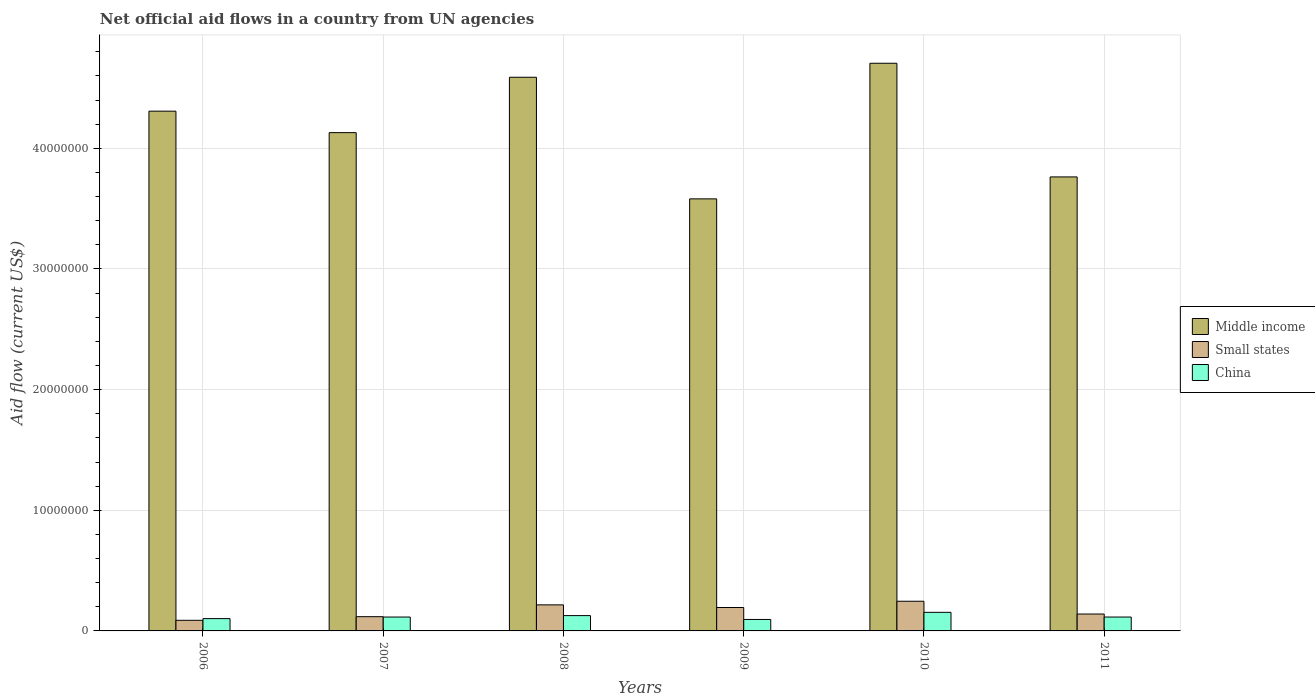How many different coloured bars are there?
Give a very brief answer. 3. How many groups of bars are there?
Your response must be concise. 6. Are the number of bars per tick equal to the number of legend labels?
Make the answer very short. Yes. Are the number of bars on each tick of the X-axis equal?
Keep it short and to the point. Yes. In how many cases, is the number of bars for a given year not equal to the number of legend labels?
Your response must be concise. 0. What is the net official aid flow in Small states in 2006?
Provide a short and direct response. 8.80e+05. Across all years, what is the maximum net official aid flow in China?
Make the answer very short. 1.54e+06. Across all years, what is the minimum net official aid flow in Middle income?
Offer a terse response. 3.58e+07. In which year was the net official aid flow in Middle income maximum?
Give a very brief answer. 2010. What is the total net official aid flow in Small states in the graph?
Provide a succinct answer. 1.00e+07. What is the difference between the net official aid flow in China in 2008 and that in 2011?
Give a very brief answer. 1.20e+05. What is the difference between the net official aid flow in Small states in 2010 and the net official aid flow in Middle income in 2009?
Make the answer very short. -3.34e+07. What is the average net official aid flow in Middle income per year?
Your answer should be very brief. 4.18e+07. In the year 2010, what is the difference between the net official aid flow in Small states and net official aid flow in China?
Your answer should be compact. 9.20e+05. What is the ratio of the net official aid flow in Small states in 2009 to that in 2011?
Provide a succinct answer. 1.39. Is the net official aid flow in Small states in 2006 less than that in 2007?
Ensure brevity in your answer.  Yes. What is the difference between the highest and the second highest net official aid flow in China?
Make the answer very short. 2.70e+05. What is the difference between the highest and the lowest net official aid flow in Middle income?
Offer a terse response. 1.12e+07. Is the sum of the net official aid flow in Small states in 2008 and 2011 greater than the maximum net official aid flow in China across all years?
Make the answer very short. Yes. What does the 1st bar from the left in 2010 represents?
Provide a succinct answer. Middle income. What does the 2nd bar from the right in 2010 represents?
Give a very brief answer. Small states. Is it the case that in every year, the sum of the net official aid flow in Middle income and net official aid flow in Small states is greater than the net official aid flow in China?
Keep it short and to the point. Yes. What is the difference between two consecutive major ticks on the Y-axis?
Your answer should be very brief. 1.00e+07. Are the values on the major ticks of Y-axis written in scientific E-notation?
Your answer should be compact. No. Does the graph contain any zero values?
Keep it short and to the point. No. Does the graph contain grids?
Offer a terse response. Yes. How many legend labels are there?
Your response must be concise. 3. What is the title of the graph?
Offer a terse response. Net official aid flows in a country from UN agencies. Does "Panama" appear as one of the legend labels in the graph?
Give a very brief answer. No. What is the label or title of the Y-axis?
Your answer should be compact. Aid flow (current US$). What is the Aid flow (current US$) in Middle income in 2006?
Offer a very short reply. 4.31e+07. What is the Aid flow (current US$) in Small states in 2006?
Make the answer very short. 8.80e+05. What is the Aid flow (current US$) of China in 2006?
Offer a very short reply. 1.02e+06. What is the Aid flow (current US$) of Middle income in 2007?
Provide a succinct answer. 4.13e+07. What is the Aid flow (current US$) in Small states in 2007?
Your answer should be very brief. 1.18e+06. What is the Aid flow (current US$) of China in 2007?
Your response must be concise. 1.15e+06. What is the Aid flow (current US$) of Middle income in 2008?
Your answer should be compact. 4.59e+07. What is the Aid flow (current US$) of Small states in 2008?
Offer a very short reply. 2.16e+06. What is the Aid flow (current US$) in China in 2008?
Your response must be concise. 1.27e+06. What is the Aid flow (current US$) in Middle income in 2009?
Provide a short and direct response. 3.58e+07. What is the Aid flow (current US$) of Small states in 2009?
Keep it short and to the point. 1.94e+06. What is the Aid flow (current US$) of China in 2009?
Your answer should be compact. 9.50e+05. What is the Aid flow (current US$) in Middle income in 2010?
Provide a short and direct response. 4.70e+07. What is the Aid flow (current US$) in Small states in 2010?
Provide a succinct answer. 2.46e+06. What is the Aid flow (current US$) of China in 2010?
Offer a very short reply. 1.54e+06. What is the Aid flow (current US$) in Middle income in 2011?
Ensure brevity in your answer.  3.76e+07. What is the Aid flow (current US$) of Small states in 2011?
Provide a succinct answer. 1.40e+06. What is the Aid flow (current US$) in China in 2011?
Give a very brief answer. 1.15e+06. Across all years, what is the maximum Aid flow (current US$) in Middle income?
Ensure brevity in your answer.  4.70e+07. Across all years, what is the maximum Aid flow (current US$) in Small states?
Provide a succinct answer. 2.46e+06. Across all years, what is the maximum Aid flow (current US$) in China?
Your answer should be very brief. 1.54e+06. Across all years, what is the minimum Aid flow (current US$) of Middle income?
Make the answer very short. 3.58e+07. Across all years, what is the minimum Aid flow (current US$) in Small states?
Provide a short and direct response. 8.80e+05. Across all years, what is the minimum Aid flow (current US$) in China?
Give a very brief answer. 9.50e+05. What is the total Aid flow (current US$) in Middle income in the graph?
Keep it short and to the point. 2.51e+08. What is the total Aid flow (current US$) in Small states in the graph?
Provide a succinct answer. 1.00e+07. What is the total Aid flow (current US$) of China in the graph?
Give a very brief answer. 7.08e+06. What is the difference between the Aid flow (current US$) in Middle income in 2006 and that in 2007?
Give a very brief answer. 1.78e+06. What is the difference between the Aid flow (current US$) of China in 2006 and that in 2007?
Offer a very short reply. -1.30e+05. What is the difference between the Aid flow (current US$) in Middle income in 2006 and that in 2008?
Make the answer very short. -2.81e+06. What is the difference between the Aid flow (current US$) of Small states in 2006 and that in 2008?
Give a very brief answer. -1.28e+06. What is the difference between the Aid flow (current US$) of China in 2006 and that in 2008?
Offer a very short reply. -2.50e+05. What is the difference between the Aid flow (current US$) of Middle income in 2006 and that in 2009?
Your response must be concise. 7.27e+06. What is the difference between the Aid flow (current US$) in Small states in 2006 and that in 2009?
Your answer should be compact. -1.06e+06. What is the difference between the Aid flow (current US$) in Middle income in 2006 and that in 2010?
Your answer should be very brief. -3.97e+06. What is the difference between the Aid flow (current US$) of Small states in 2006 and that in 2010?
Ensure brevity in your answer.  -1.58e+06. What is the difference between the Aid flow (current US$) in China in 2006 and that in 2010?
Your response must be concise. -5.20e+05. What is the difference between the Aid flow (current US$) in Middle income in 2006 and that in 2011?
Make the answer very short. 5.45e+06. What is the difference between the Aid flow (current US$) in Small states in 2006 and that in 2011?
Offer a very short reply. -5.20e+05. What is the difference between the Aid flow (current US$) in China in 2006 and that in 2011?
Ensure brevity in your answer.  -1.30e+05. What is the difference between the Aid flow (current US$) of Middle income in 2007 and that in 2008?
Provide a succinct answer. -4.59e+06. What is the difference between the Aid flow (current US$) in Small states in 2007 and that in 2008?
Offer a terse response. -9.80e+05. What is the difference between the Aid flow (current US$) in Middle income in 2007 and that in 2009?
Offer a very short reply. 5.49e+06. What is the difference between the Aid flow (current US$) of Small states in 2007 and that in 2009?
Provide a succinct answer. -7.60e+05. What is the difference between the Aid flow (current US$) of China in 2007 and that in 2009?
Offer a terse response. 2.00e+05. What is the difference between the Aid flow (current US$) of Middle income in 2007 and that in 2010?
Ensure brevity in your answer.  -5.75e+06. What is the difference between the Aid flow (current US$) of Small states in 2007 and that in 2010?
Ensure brevity in your answer.  -1.28e+06. What is the difference between the Aid flow (current US$) of China in 2007 and that in 2010?
Give a very brief answer. -3.90e+05. What is the difference between the Aid flow (current US$) in Middle income in 2007 and that in 2011?
Provide a short and direct response. 3.67e+06. What is the difference between the Aid flow (current US$) in Small states in 2007 and that in 2011?
Keep it short and to the point. -2.20e+05. What is the difference between the Aid flow (current US$) in China in 2007 and that in 2011?
Keep it short and to the point. 0. What is the difference between the Aid flow (current US$) in Middle income in 2008 and that in 2009?
Your answer should be very brief. 1.01e+07. What is the difference between the Aid flow (current US$) of Small states in 2008 and that in 2009?
Your answer should be compact. 2.20e+05. What is the difference between the Aid flow (current US$) of China in 2008 and that in 2009?
Offer a terse response. 3.20e+05. What is the difference between the Aid flow (current US$) of Middle income in 2008 and that in 2010?
Make the answer very short. -1.16e+06. What is the difference between the Aid flow (current US$) in China in 2008 and that in 2010?
Provide a short and direct response. -2.70e+05. What is the difference between the Aid flow (current US$) of Middle income in 2008 and that in 2011?
Make the answer very short. 8.26e+06. What is the difference between the Aid flow (current US$) of Small states in 2008 and that in 2011?
Your answer should be compact. 7.60e+05. What is the difference between the Aid flow (current US$) of Middle income in 2009 and that in 2010?
Keep it short and to the point. -1.12e+07. What is the difference between the Aid flow (current US$) in Small states in 2009 and that in 2010?
Offer a very short reply. -5.20e+05. What is the difference between the Aid flow (current US$) in China in 2009 and that in 2010?
Provide a succinct answer. -5.90e+05. What is the difference between the Aid flow (current US$) in Middle income in 2009 and that in 2011?
Provide a short and direct response. -1.82e+06. What is the difference between the Aid flow (current US$) in Small states in 2009 and that in 2011?
Offer a very short reply. 5.40e+05. What is the difference between the Aid flow (current US$) in China in 2009 and that in 2011?
Provide a short and direct response. -2.00e+05. What is the difference between the Aid flow (current US$) of Middle income in 2010 and that in 2011?
Offer a terse response. 9.42e+06. What is the difference between the Aid flow (current US$) in Small states in 2010 and that in 2011?
Give a very brief answer. 1.06e+06. What is the difference between the Aid flow (current US$) of China in 2010 and that in 2011?
Make the answer very short. 3.90e+05. What is the difference between the Aid flow (current US$) of Middle income in 2006 and the Aid flow (current US$) of Small states in 2007?
Give a very brief answer. 4.19e+07. What is the difference between the Aid flow (current US$) in Middle income in 2006 and the Aid flow (current US$) in China in 2007?
Give a very brief answer. 4.19e+07. What is the difference between the Aid flow (current US$) in Small states in 2006 and the Aid flow (current US$) in China in 2007?
Your answer should be very brief. -2.70e+05. What is the difference between the Aid flow (current US$) in Middle income in 2006 and the Aid flow (current US$) in Small states in 2008?
Your answer should be compact. 4.09e+07. What is the difference between the Aid flow (current US$) in Middle income in 2006 and the Aid flow (current US$) in China in 2008?
Your answer should be very brief. 4.18e+07. What is the difference between the Aid flow (current US$) of Small states in 2006 and the Aid flow (current US$) of China in 2008?
Your answer should be very brief. -3.90e+05. What is the difference between the Aid flow (current US$) in Middle income in 2006 and the Aid flow (current US$) in Small states in 2009?
Provide a short and direct response. 4.11e+07. What is the difference between the Aid flow (current US$) in Middle income in 2006 and the Aid flow (current US$) in China in 2009?
Your response must be concise. 4.21e+07. What is the difference between the Aid flow (current US$) in Middle income in 2006 and the Aid flow (current US$) in Small states in 2010?
Make the answer very short. 4.06e+07. What is the difference between the Aid flow (current US$) of Middle income in 2006 and the Aid flow (current US$) of China in 2010?
Your answer should be very brief. 4.15e+07. What is the difference between the Aid flow (current US$) of Small states in 2006 and the Aid flow (current US$) of China in 2010?
Your answer should be compact. -6.60e+05. What is the difference between the Aid flow (current US$) of Middle income in 2006 and the Aid flow (current US$) of Small states in 2011?
Your answer should be very brief. 4.17e+07. What is the difference between the Aid flow (current US$) of Middle income in 2006 and the Aid flow (current US$) of China in 2011?
Make the answer very short. 4.19e+07. What is the difference between the Aid flow (current US$) in Middle income in 2007 and the Aid flow (current US$) in Small states in 2008?
Give a very brief answer. 3.91e+07. What is the difference between the Aid flow (current US$) in Middle income in 2007 and the Aid flow (current US$) in China in 2008?
Make the answer very short. 4.00e+07. What is the difference between the Aid flow (current US$) in Small states in 2007 and the Aid flow (current US$) in China in 2008?
Give a very brief answer. -9.00e+04. What is the difference between the Aid flow (current US$) in Middle income in 2007 and the Aid flow (current US$) in Small states in 2009?
Offer a terse response. 3.94e+07. What is the difference between the Aid flow (current US$) in Middle income in 2007 and the Aid flow (current US$) in China in 2009?
Give a very brief answer. 4.04e+07. What is the difference between the Aid flow (current US$) of Middle income in 2007 and the Aid flow (current US$) of Small states in 2010?
Your answer should be very brief. 3.88e+07. What is the difference between the Aid flow (current US$) in Middle income in 2007 and the Aid flow (current US$) in China in 2010?
Your response must be concise. 3.98e+07. What is the difference between the Aid flow (current US$) of Small states in 2007 and the Aid flow (current US$) of China in 2010?
Provide a succinct answer. -3.60e+05. What is the difference between the Aid flow (current US$) of Middle income in 2007 and the Aid flow (current US$) of Small states in 2011?
Your answer should be compact. 3.99e+07. What is the difference between the Aid flow (current US$) in Middle income in 2007 and the Aid flow (current US$) in China in 2011?
Offer a very short reply. 4.02e+07. What is the difference between the Aid flow (current US$) in Middle income in 2008 and the Aid flow (current US$) in Small states in 2009?
Keep it short and to the point. 4.40e+07. What is the difference between the Aid flow (current US$) in Middle income in 2008 and the Aid flow (current US$) in China in 2009?
Your response must be concise. 4.49e+07. What is the difference between the Aid flow (current US$) of Small states in 2008 and the Aid flow (current US$) of China in 2009?
Offer a terse response. 1.21e+06. What is the difference between the Aid flow (current US$) of Middle income in 2008 and the Aid flow (current US$) of Small states in 2010?
Give a very brief answer. 4.34e+07. What is the difference between the Aid flow (current US$) in Middle income in 2008 and the Aid flow (current US$) in China in 2010?
Provide a succinct answer. 4.44e+07. What is the difference between the Aid flow (current US$) in Small states in 2008 and the Aid flow (current US$) in China in 2010?
Offer a terse response. 6.20e+05. What is the difference between the Aid flow (current US$) of Middle income in 2008 and the Aid flow (current US$) of Small states in 2011?
Your answer should be compact. 4.45e+07. What is the difference between the Aid flow (current US$) of Middle income in 2008 and the Aid flow (current US$) of China in 2011?
Your answer should be very brief. 4.47e+07. What is the difference between the Aid flow (current US$) in Small states in 2008 and the Aid flow (current US$) in China in 2011?
Ensure brevity in your answer.  1.01e+06. What is the difference between the Aid flow (current US$) of Middle income in 2009 and the Aid flow (current US$) of Small states in 2010?
Provide a short and direct response. 3.34e+07. What is the difference between the Aid flow (current US$) in Middle income in 2009 and the Aid flow (current US$) in China in 2010?
Your answer should be very brief. 3.43e+07. What is the difference between the Aid flow (current US$) of Small states in 2009 and the Aid flow (current US$) of China in 2010?
Your answer should be compact. 4.00e+05. What is the difference between the Aid flow (current US$) in Middle income in 2009 and the Aid flow (current US$) in Small states in 2011?
Provide a short and direct response. 3.44e+07. What is the difference between the Aid flow (current US$) in Middle income in 2009 and the Aid flow (current US$) in China in 2011?
Offer a very short reply. 3.47e+07. What is the difference between the Aid flow (current US$) of Small states in 2009 and the Aid flow (current US$) of China in 2011?
Make the answer very short. 7.90e+05. What is the difference between the Aid flow (current US$) of Middle income in 2010 and the Aid flow (current US$) of Small states in 2011?
Provide a succinct answer. 4.56e+07. What is the difference between the Aid flow (current US$) in Middle income in 2010 and the Aid flow (current US$) in China in 2011?
Offer a terse response. 4.59e+07. What is the difference between the Aid flow (current US$) of Small states in 2010 and the Aid flow (current US$) of China in 2011?
Your response must be concise. 1.31e+06. What is the average Aid flow (current US$) in Middle income per year?
Offer a terse response. 4.18e+07. What is the average Aid flow (current US$) in Small states per year?
Provide a succinct answer. 1.67e+06. What is the average Aid flow (current US$) of China per year?
Give a very brief answer. 1.18e+06. In the year 2006, what is the difference between the Aid flow (current US$) of Middle income and Aid flow (current US$) of Small states?
Your response must be concise. 4.22e+07. In the year 2006, what is the difference between the Aid flow (current US$) in Middle income and Aid flow (current US$) in China?
Ensure brevity in your answer.  4.21e+07. In the year 2007, what is the difference between the Aid flow (current US$) of Middle income and Aid flow (current US$) of Small states?
Ensure brevity in your answer.  4.01e+07. In the year 2007, what is the difference between the Aid flow (current US$) of Middle income and Aid flow (current US$) of China?
Your response must be concise. 4.02e+07. In the year 2007, what is the difference between the Aid flow (current US$) of Small states and Aid flow (current US$) of China?
Give a very brief answer. 3.00e+04. In the year 2008, what is the difference between the Aid flow (current US$) in Middle income and Aid flow (current US$) in Small states?
Your answer should be very brief. 4.37e+07. In the year 2008, what is the difference between the Aid flow (current US$) of Middle income and Aid flow (current US$) of China?
Your answer should be very brief. 4.46e+07. In the year 2008, what is the difference between the Aid flow (current US$) in Small states and Aid flow (current US$) in China?
Give a very brief answer. 8.90e+05. In the year 2009, what is the difference between the Aid flow (current US$) in Middle income and Aid flow (current US$) in Small states?
Provide a succinct answer. 3.39e+07. In the year 2009, what is the difference between the Aid flow (current US$) of Middle income and Aid flow (current US$) of China?
Your response must be concise. 3.49e+07. In the year 2009, what is the difference between the Aid flow (current US$) in Small states and Aid flow (current US$) in China?
Keep it short and to the point. 9.90e+05. In the year 2010, what is the difference between the Aid flow (current US$) in Middle income and Aid flow (current US$) in Small states?
Offer a very short reply. 4.46e+07. In the year 2010, what is the difference between the Aid flow (current US$) of Middle income and Aid flow (current US$) of China?
Offer a terse response. 4.55e+07. In the year 2010, what is the difference between the Aid flow (current US$) in Small states and Aid flow (current US$) in China?
Keep it short and to the point. 9.20e+05. In the year 2011, what is the difference between the Aid flow (current US$) of Middle income and Aid flow (current US$) of Small states?
Provide a succinct answer. 3.62e+07. In the year 2011, what is the difference between the Aid flow (current US$) in Middle income and Aid flow (current US$) in China?
Keep it short and to the point. 3.65e+07. In the year 2011, what is the difference between the Aid flow (current US$) of Small states and Aid flow (current US$) of China?
Make the answer very short. 2.50e+05. What is the ratio of the Aid flow (current US$) of Middle income in 2006 to that in 2007?
Offer a terse response. 1.04. What is the ratio of the Aid flow (current US$) in Small states in 2006 to that in 2007?
Offer a terse response. 0.75. What is the ratio of the Aid flow (current US$) in China in 2006 to that in 2007?
Make the answer very short. 0.89. What is the ratio of the Aid flow (current US$) of Middle income in 2006 to that in 2008?
Offer a terse response. 0.94. What is the ratio of the Aid flow (current US$) in Small states in 2006 to that in 2008?
Ensure brevity in your answer.  0.41. What is the ratio of the Aid flow (current US$) of China in 2006 to that in 2008?
Offer a very short reply. 0.8. What is the ratio of the Aid flow (current US$) of Middle income in 2006 to that in 2009?
Your response must be concise. 1.2. What is the ratio of the Aid flow (current US$) of Small states in 2006 to that in 2009?
Keep it short and to the point. 0.45. What is the ratio of the Aid flow (current US$) of China in 2006 to that in 2009?
Ensure brevity in your answer.  1.07. What is the ratio of the Aid flow (current US$) in Middle income in 2006 to that in 2010?
Keep it short and to the point. 0.92. What is the ratio of the Aid flow (current US$) in Small states in 2006 to that in 2010?
Your answer should be very brief. 0.36. What is the ratio of the Aid flow (current US$) in China in 2006 to that in 2010?
Give a very brief answer. 0.66. What is the ratio of the Aid flow (current US$) of Middle income in 2006 to that in 2011?
Your response must be concise. 1.14. What is the ratio of the Aid flow (current US$) of Small states in 2006 to that in 2011?
Make the answer very short. 0.63. What is the ratio of the Aid flow (current US$) of China in 2006 to that in 2011?
Ensure brevity in your answer.  0.89. What is the ratio of the Aid flow (current US$) in Middle income in 2007 to that in 2008?
Provide a succinct answer. 0.9. What is the ratio of the Aid flow (current US$) in Small states in 2007 to that in 2008?
Offer a very short reply. 0.55. What is the ratio of the Aid flow (current US$) in China in 2007 to that in 2008?
Offer a terse response. 0.91. What is the ratio of the Aid flow (current US$) in Middle income in 2007 to that in 2009?
Provide a succinct answer. 1.15. What is the ratio of the Aid flow (current US$) of Small states in 2007 to that in 2009?
Provide a short and direct response. 0.61. What is the ratio of the Aid flow (current US$) of China in 2007 to that in 2009?
Your answer should be very brief. 1.21. What is the ratio of the Aid flow (current US$) of Middle income in 2007 to that in 2010?
Provide a succinct answer. 0.88. What is the ratio of the Aid flow (current US$) in Small states in 2007 to that in 2010?
Make the answer very short. 0.48. What is the ratio of the Aid flow (current US$) of China in 2007 to that in 2010?
Your response must be concise. 0.75. What is the ratio of the Aid flow (current US$) in Middle income in 2007 to that in 2011?
Keep it short and to the point. 1.1. What is the ratio of the Aid flow (current US$) in Small states in 2007 to that in 2011?
Provide a short and direct response. 0.84. What is the ratio of the Aid flow (current US$) of China in 2007 to that in 2011?
Make the answer very short. 1. What is the ratio of the Aid flow (current US$) in Middle income in 2008 to that in 2009?
Your answer should be very brief. 1.28. What is the ratio of the Aid flow (current US$) in Small states in 2008 to that in 2009?
Give a very brief answer. 1.11. What is the ratio of the Aid flow (current US$) in China in 2008 to that in 2009?
Keep it short and to the point. 1.34. What is the ratio of the Aid flow (current US$) in Middle income in 2008 to that in 2010?
Provide a short and direct response. 0.98. What is the ratio of the Aid flow (current US$) of Small states in 2008 to that in 2010?
Give a very brief answer. 0.88. What is the ratio of the Aid flow (current US$) in China in 2008 to that in 2010?
Give a very brief answer. 0.82. What is the ratio of the Aid flow (current US$) of Middle income in 2008 to that in 2011?
Provide a short and direct response. 1.22. What is the ratio of the Aid flow (current US$) in Small states in 2008 to that in 2011?
Make the answer very short. 1.54. What is the ratio of the Aid flow (current US$) in China in 2008 to that in 2011?
Keep it short and to the point. 1.1. What is the ratio of the Aid flow (current US$) in Middle income in 2009 to that in 2010?
Provide a succinct answer. 0.76. What is the ratio of the Aid flow (current US$) of Small states in 2009 to that in 2010?
Keep it short and to the point. 0.79. What is the ratio of the Aid flow (current US$) of China in 2009 to that in 2010?
Offer a very short reply. 0.62. What is the ratio of the Aid flow (current US$) in Middle income in 2009 to that in 2011?
Offer a very short reply. 0.95. What is the ratio of the Aid flow (current US$) in Small states in 2009 to that in 2011?
Make the answer very short. 1.39. What is the ratio of the Aid flow (current US$) of China in 2009 to that in 2011?
Keep it short and to the point. 0.83. What is the ratio of the Aid flow (current US$) in Middle income in 2010 to that in 2011?
Provide a short and direct response. 1.25. What is the ratio of the Aid flow (current US$) in Small states in 2010 to that in 2011?
Ensure brevity in your answer.  1.76. What is the ratio of the Aid flow (current US$) in China in 2010 to that in 2011?
Offer a very short reply. 1.34. What is the difference between the highest and the second highest Aid flow (current US$) of Middle income?
Offer a terse response. 1.16e+06. What is the difference between the highest and the second highest Aid flow (current US$) in China?
Offer a terse response. 2.70e+05. What is the difference between the highest and the lowest Aid flow (current US$) of Middle income?
Provide a short and direct response. 1.12e+07. What is the difference between the highest and the lowest Aid flow (current US$) of Small states?
Ensure brevity in your answer.  1.58e+06. What is the difference between the highest and the lowest Aid flow (current US$) in China?
Your response must be concise. 5.90e+05. 